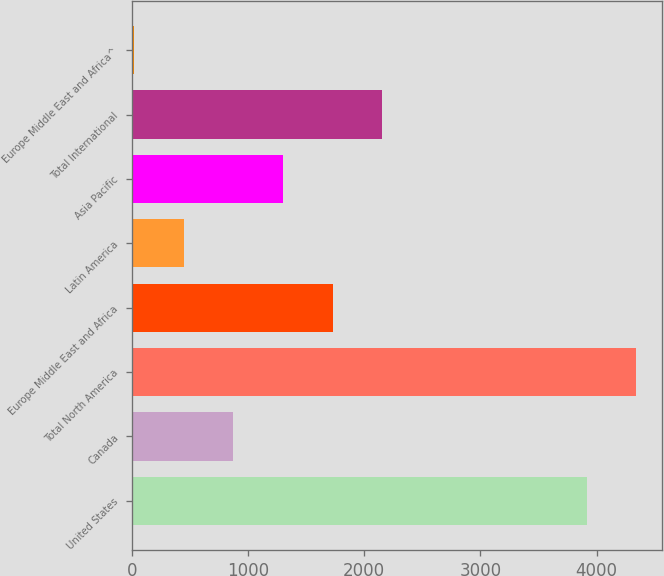<chart> <loc_0><loc_0><loc_500><loc_500><bar_chart><fcel>United States<fcel>Canada<fcel>Total North America<fcel>Europe Middle East and Africa<fcel>Latin America<fcel>Asia Pacific<fcel>Total International<fcel>Europe Middle East and Africa^<nl><fcel>3915.7<fcel>871.68<fcel>4343.24<fcel>1726.76<fcel>444.14<fcel>1299.22<fcel>2154.3<fcel>16.6<nl></chart> 